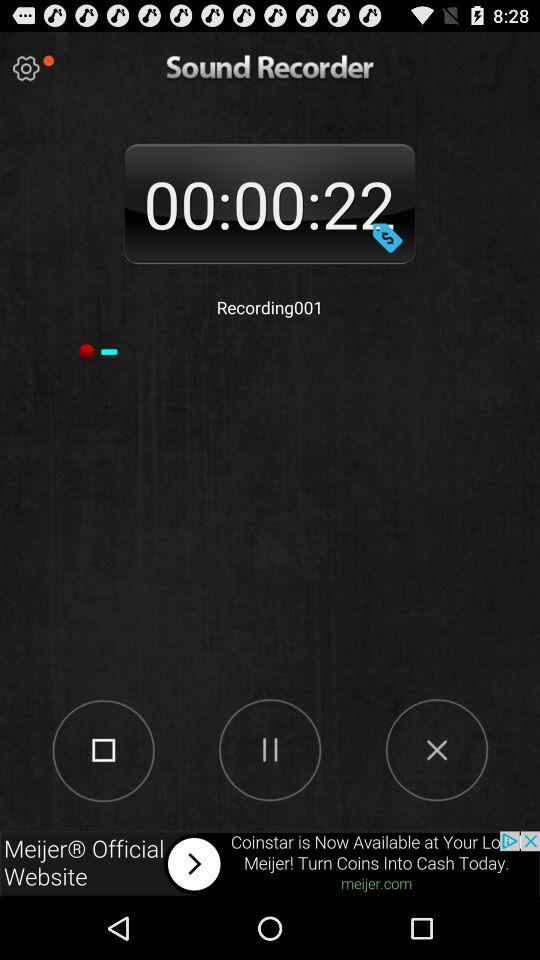What is the duration of the recording? The duration of the recording is 00:00:22. 